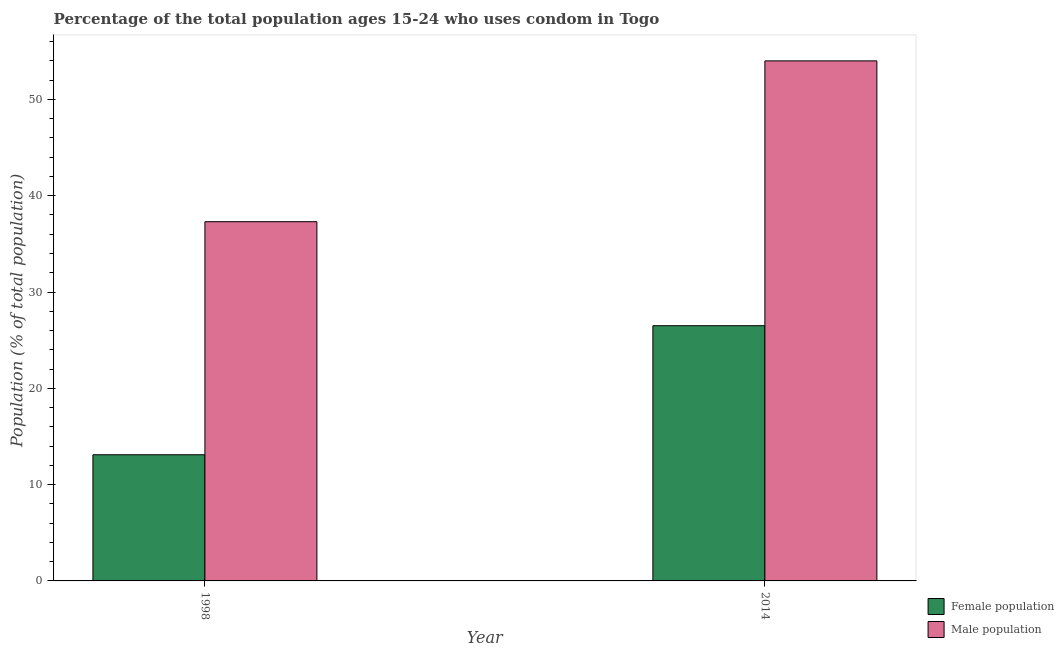How many different coloured bars are there?
Keep it short and to the point. 2. How many bars are there on the 2nd tick from the left?
Provide a succinct answer. 2. How many bars are there on the 1st tick from the right?
Offer a terse response. 2. Across all years, what is the maximum male population?
Make the answer very short. 54. Across all years, what is the minimum male population?
Your answer should be very brief. 37.3. In which year was the male population maximum?
Make the answer very short. 2014. In which year was the female population minimum?
Ensure brevity in your answer.  1998. What is the total female population in the graph?
Your response must be concise. 39.6. What is the difference between the male population in 2014 and the female population in 1998?
Your response must be concise. 16.7. What is the average female population per year?
Your answer should be compact. 19.8. In how many years, is the female population greater than 16 %?
Give a very brief answer. 1. What is the ratio of the male population in 1998 to that in 2014?
Make the answer very short. 0.69. Is the male population in 1998 less than that in 2014?
Give a very brief answer. Yes. What does the 1st bar from the left in 1998 represents?
Ensure brevity in your answer.  Female population. What does the 1st bar from the right in 1998 represents?
Give a very brief answer. Male population. How many years are there in the graph?
Your answer should be very brief. 2. Does the graph contain any zero values?
Your answer should be very brief. No. Does the graph contain grids?
Offer a terse response. No. How are the legend labels stacked?
Give a very brief answer. Vertical. What is the title of the graph?
Provide a short and direct response. Percentage of the total population ages 15-24 who uses condom in Togo. Does "Drinking water services" appear as one of the legend labels in the graph?
Your response must be concise. No. What is the label or title of the Y-axis?
Offer a terse response. Population (% of total population) . What is the Population (% of total population)  of Male population in 1998?
Ensure brevity in your answer.  37.3. Across all years, what is the maximum Population (% of total population)  in Female population?
Your response must be concise. 26.5. Across all years, what is the minimum Population (% of total population)  in Male population?
Make the answer very short. 37.3. What is the total Population (% of total population)  in Female population in the graph?
Offer a very short reply. 39.6. What is the total Population (% of total population)  in Male population in the graph?
Offer a very short reply. 91.3. What is the difference between the Population (% of total population)  in Male population in 1998 and that in 2014?
Give a very brief answer. -16.7. What is the difference between the Population (% of total population)  of Female population in 1998 and the Population (% of total population)  of Male population in 2014?
Your answer should be very brief. -40.9. What is the average Population (% of total population)  in Female population per year?
Your answer should be very brief. 19.8. What is the average Population (% of total population)  of Male population per year?
Provide a short and direct response. 45.65. In the year 1998, what is the difference between the Population (% of total population)  in Female population and Population (% of total population)  in Male population?
Provide a short and direct response. -24.2. In the year 2014, what is the difference between the Population (% of total population)  of Female population and Population (% of total population)  of Male population?
Your answer should be very brief. -27.5. What is the ratio of the Population (% of total population)  of Female population in 1998 to that in 2014?
Offer a very short reply. 0.49. What is the ratio of the Population (% of total population)  in Male population in 1998 to that in 2014?
Make the answer very short. 0.69. 